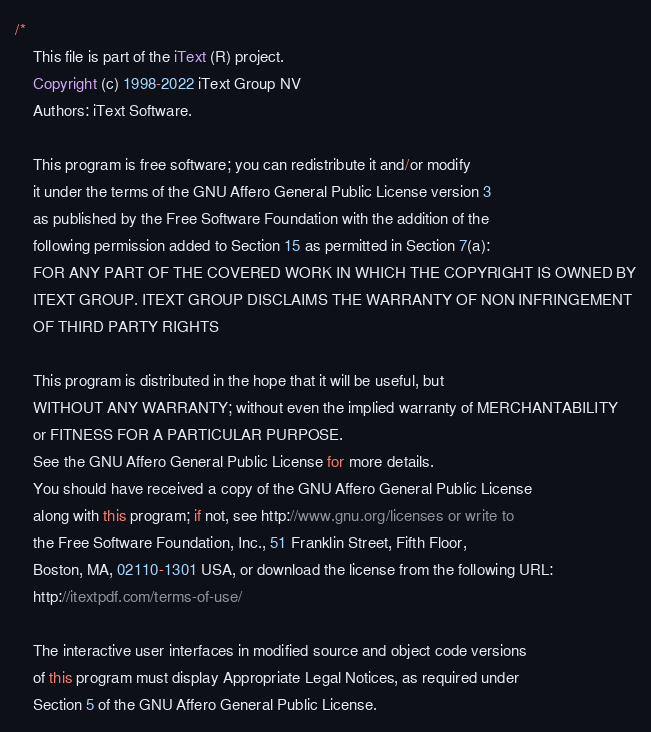<code> <loc_0><loc_0><loc_500><loc_500><_Java_>/*
    This file is part of the iText (R) project.
    Copyright (c) 1998-2022 iText Group NV
    Authors: iText Software.

    This program is free software; you can redistribute it and/or modify
    it under the terms of the GNU Affero General Public License version 3
    as published by the Free Software Foundation with the addition of the
    following permission added to Section 15 as permitted in Section 7(a):
    FOR ANY PART OF THE COVERED WORK IN WHICH THE COPYRIGHT IS OWNED BY
    ITEXT GROUP. ITEXT GROUP DISCLAIMS THE WARRANTY OF NON INFRINGEMENT
    OF THIRD PARTY RIGHTS

    This program is distributed in the hope that it will be useful, but
    WITHOUT ANY WARRANTY; without even the implied warranty of MERCHANTABILITY
    or FITNESS FOR A PARTICULAR PURPOSE.
    See the GNU Affero General Public License for more details.
    You should have received a copy of the GNU Affero General Public License
    along with this program; if not, see http://www.gnu.org/licenses or write to
    the Free Software Foundation, Inc., 51 Franklin Street, Fifth Floor,
    Boston, MA, 02110-1301 USA, or download the license from the following URL:
    http://itextpdf.com/terms-of-use/

    The interactive user interfaces in modified source and object code versions
    of this program must display Appropriate Legal Notices, as required under
    Section 5 of the GNU Affero General Public License.
</code> 